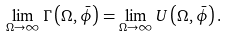Convert formula to latex. <formula><loc_0><loc_0><loc_500><loc_500>\lim _ { \Omega \to \infty } \Gamma \left ( \Omega , \bar { \phi } \right ) = \lim _ { \Omega \to \infty } U \left ( \Omega , \bar { \phi } \right ) .</formula> 